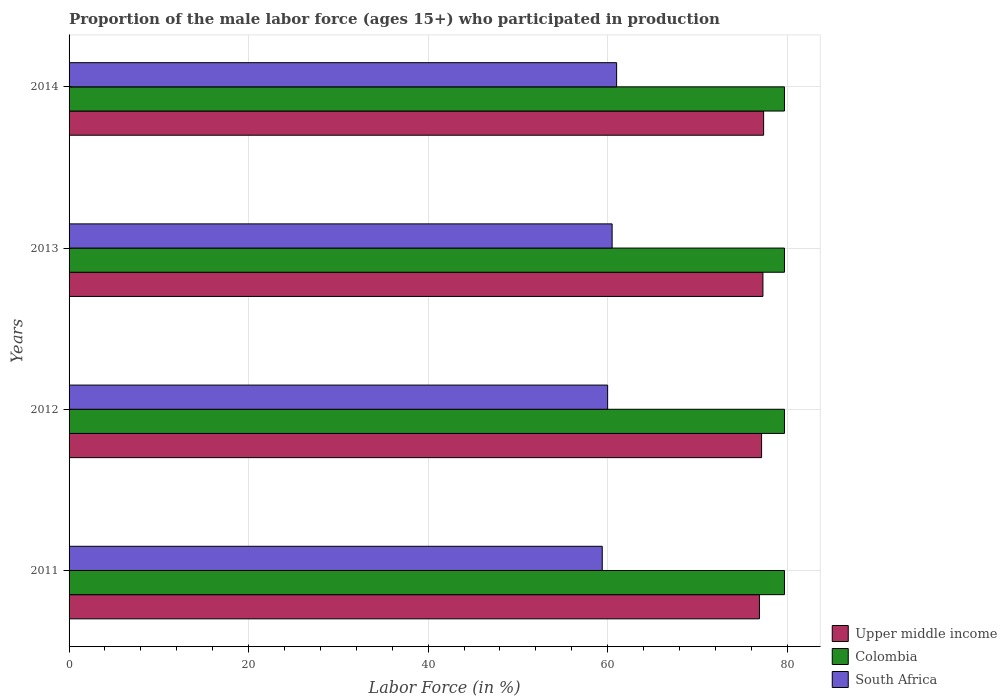How many different coloured bars are there?
Your answer should be compact. 3. Are the number of bars per tick equal to the number of legend labels?
Ensure brevity in your answer.  Yes. Are the number of bars on each tick of the Y-axis equal?
Ensure brevity in your answer.  Yes. How many bars are there on the 3rd tick from the top?
Keep it short and to the point. 3. How many bars are there on the 1st tick from the bottom?
Keep it short and to the point. 3. What is the proportion of the male labor force who participated in production in Colombia in 2011?
Ensure brevity in your answer.  79.7. Across all years, what is the maximum proportion of the male labor force who participated in production in Upper middle income?
Keep it short and to the point. 77.38. Across all years, what is the minimum proportion of the male labor force who participated in production in South Africa?
Offer a terse response. 59.4. In which year was the proportion of the male labor force who participated in production in Upper middle income maximum?
Keep it short and to the point. 2014. In which year was the proportion of the male labor force who participated in production in Upper middle income minimum?
Your answer should be very brief. 2011. What is the total proportion of the male labor force who participated in production in Upper middle income in the graph?
Provide a succinct answer. 308.74. What is the difference between the proportion of the male labor force who participated in production in South Africa in 2011 and that in 2013?
Your response must be concise. -1.1. What is the difference between the proportion of the male labor force who participated in production in South Africa in 2014 and the proportion of the male labor force who participated in production in Colombia in 2012?
Ensure brevity in your answer.  -18.7. What is the average proportion of the male labor force who participated in production in South Africa per year?
Offer a very short reply. 60.23. In the year 2012, what is the difference between the proportion of the male labor force who participated in production in South Africa and proportion of the male labor force who participated in production in Upper middle income?
Offer a very short reply. -17.15. In how many years, is the proportion of the male labor force who participated in production in South Africa greater than 56 %?
Your answer should be compact. 4. What is the ratio of the proportion of the male labor force who participated in production in South Africa in 2011 to that in 2014?
Your answer should be compact. 0.97. Is the proportion of the male labor force who participated in production in Colombia in 2011 less than that in 2014?
Your answer should be compact. No. Is the difference between the proportion of the male labor force who participated in production in South Africa in 2011 and 2012 greater than the difference between the proportion of the male labor force who participated in production in Upper middle income in 2011 and 2012?
Your answer should be compact. No. What is the difference between the highest and the lowest proportion of the male labor force who participated in production in Upper middle income?
Offer a terse response. 0.46. In how many years, is the proportion of the male labor force who participated in production in South Africa greater than the average proportion of the male labor force who participated in production in South Africa taken over all years?
Your response must be concise. 2. What does the 1st bar from the top in 2013 represents?
Give a very brief answer. South Africa. What does the 1st bar from the bottom in 2011 represents?
Ensure brevity in your answer.  Upper middle income. Is it the case that in every year, the sum of the proportion of the male labor force who participated in production in South Africa and proportion of the male labor force who participated in production in Colombia is greater than the proportion of the male labor force who participated in production in Upper middle income?
Keep it short and to the point. Yes. How many bars are there?
Your answer should be compact. 12. Are all the bars in the graph horizontal?
Provide a short and direct response. Yes. How many years are there in the graph?
Provide a succinct answer. 4. What is the difference between two consecutive major ticks on the X-axis?
Your response must be concise. 20. Are the values on the major ticks of X-axis written in scientific E-notation?
Provide a short and direct response. No. Where does the legend appear in the graph?
Your answer should be compact. Bottom right. How many legend labels are there?
Offer a very short reply. 3. How are the legend labels stacked?
Make the answer very short. Vertical. What is the title of the graph?
Your response must be concise. Proportion of the male labor force (ages 15+) who participated in production. What is the Labor Force (in %) in Upper middle income in 2011?
Your answer should be compact. 76.91. What is the Labor Force (in %) of Colombia in 2011?
Give a very brief answer. 79.7. What is the Labor Force (in %) in South Africa in 2011?
Your response must be concise. 59.4. What is the Labor Force (in %) of Upper middle income in 2012?
Your response must be concise. 77.15. What is the Labor Force (in %) in Colombia in 2012?
Your answer should be very brief. 79.7. What is the Labor Force (in %) of Upper middle income in 2013?
Offer a very short reply. 77.3. What is the Labor Force (in %) in Colombia in 2013?
Keep it short and to the point. 79.7. What is the Labor Force (in %) of South Africa in 2013?
Provide a short and direct response. 60.5. What is the Labor Force (in %) in Upper middle income in 2014?
Your answer should be very brief. 77.38. What is the Labor Force (in %) of Colombia in 2014?
Your response must be concise. 79.7. Across all years, what is the maximum Labor Force (in %) in Upper middle income?
Make the answer very short. 77.38. Across all years, what is the maximum Labor Force (in %) in Colombia?
Your answer should be compact. 79.7. Across all years, what is the minimum Labor Force (in %) of Upper middle income?
Your answer should be very brief. 76.91. Across all years, what is the minimum Labor Force (in %) of Colombia?
Your response must be concise. 79.7. Across all years, what is the minimum Labor Force (in %) of South Africa?
Offer a very short reply. 59.4. What is the total Labor Force (in %) in Upper middle income in the graph?
Ensure brevity in your answer.  308.74. What is the total Labor Force (in %) of Colombia in the graph?
Make the answer very short. 318.8. What is the total Labor Force (in %) in South Africa in the graph?
Your answer should be compact. 240.9. What is the difference between the Labor Force (in %) in Upper middle income in 2011 and that in 2012?
Make the answer very short. -0.24. What is the difference between the Labor Force (in %) of Colombia in 2011 and that in 2012?
Ensure brevity in your answer.  0. What is the difference between the Labor Force (in %) of Upper middle income in 2011 and that in 2013?
Offer a very short reply. -0.39. What is the difference between the Labor Force (in %) in Upper middle income in 2011 and that in 2014?
Ensure brevity in your answer.  -0.46. What is the difference between the Labor Force (in %) of Colombia in 2011 and that in 2014?
Provide a succinct answer. 0. What is the difference between the Labor Force (in %) in South Africa in 2011 and that in 2014?
Your answer should be compact. -1.6. What is the difference between the Labor Force (in %) in Upper middle income in 2012 and that in 2013?
Your answer should be very brief. -0.15. What is the difference between the Labor Force (in %) of Upper middle income in 2012 and that in 2014?
Provide a short and direct response. -0.23. What is the difference between the Labor Force (in %) in Colombia in 2012 and that in 2014?
Your answer should be very brief. 0. What is the difference between the Labor Force (in %) in Upper middle income in 2013 and that in 2014?
Your answer should be compact. -0.08. What is the difference between the Labor Force (in %) in Colombia in 2013 and that in 2014?
Make the answer very short. 0. What is the difference between the Labor Force (in %) in South Africa in 2013 and that in 2014?
Your answer should be very brief. -0.5. What is the difference between the Labor Force (in %) of Upper middle income in 2011 and the Labor Force (in %) of Colombia in 2012?
Your answer should be very brief. -2.79. What is the difference between the Labor Force (in %) of Upper middle income in 2011 and the Labor Force (in %) of South Africa in 2012?
Ensure brevity in your answer.  16.91. What is the difference between the Labor Force (in %) of Colombia in 2011 and the Labor Force (in %) of South Africa in 2012?
Ensure brevity in your answer.  19.7. What is the difference between the Labor Force (in %) of Upper middle income in 2011 and the Labor Force (in %) of Colombia in 2013?
Your response must be concise. -2.79. What is the difference between the Labor Force (in %) in Upper middle income in 2011 and the Labor Force (in %) in South Africa in 2013?
Offer a terse response. 16.41. What is the difference between the Labor Force (in %) in Upper middle income in 2011 and the Labor Force (in %) in Colombia in 2014?
Make the answer very short. -2.79. What is the difference between the Labor Force (in %) of Upper middle income in 2011 and the Labor Force (in %) of South Africa in 2014?
Provide a short and direct response. 15.91. What is the difference between the Labor Force (in %) in Upper middle income in 2012 and the Labor Force (in %) in Colombia in 2013?
Make the answer very short. -2.55. What is the difference between the Labor Force (in %) of Upper middle income in 2012 and the Labor Force (in %) of South Africa in 2013?
Provide a short and direct response. 16.65. What is the difference between the Labor Force (in %) in Colombia in 2012 and the Labor Force (in %) in South Africa in 2013?
Make the answer very short. 19.2. What is the difference between the Labor Force (in %) of Upper middle income in 2012 and the Labor Force (in %) of Colombia in 2014?
Make the answer very short. -2.55. What is the difference between the Labor Force (in %) of Upper middle income in 2012 and the Labor Force (in %) of South Africa in 2014?
Offer a terse response. 16.15. What is the difference between the Labor Force (in %) of Colombia in 2012 and the Labor Force (in %) of South Africa in 2014?
Provide a short and direct response. 18.7. What is the difference between the Labor Force (in %) of Upper middle income in 2013 and the Labor Force (in %) of Colombia in 2014?
Ensure brevity in your answer.  -2.4. What is the difference between the Labor Force (in %) of Upper middle income in 2013 and the Labor Force (in %) of South Africa in 2014?
Offer a very short reply. 16.3. What is the average Labor Force (in %) in Upper middle income per year?
Your answer should be very brief. 77.19. What is the average Labor Force (in %) of Colombia per year?
Offer a terse response. 79.7. What is the average Labor Force (in %) of South Africa per year?
Ensure brevity in your answer.  60.23. In the year 2011, what is the difference between the Labor Force (in %) in Upper middle income and Labor Force (in %) in Colombia?
Offer a very short reply. -2.79. In the year 2011, what is the difference between the Labor Force (in %) of Upper middle income and Labor Force (in %) of South Africa?
Provide a short and direct response. 17.51. In the year 2011, what is the difference between the Labor Force (in %) in Colombia and Labor Force (in %) in South Africa?
Your response must be concise. 20.3. In the year 2012, what is the difference between the Labor Force (in %) of Upper middle income and Labor Force (in %) of Colombia?
Your response must be concise. -2.55. In the year 2012, what is the difference between the Labor Force (in %) of Upper middle income and Labor Force (in %) of South Africa?
Offer a terse response. 17.15. In the year 2013, what is the difference between the Labor Force (in %) in Upper middle income and Labor Force (in %) in Colombia?
Your answer should be very brief. -2.4. In the year 2013, what is the difference between the Labor Force (in %) in Upper middle income and Labor Force (in %) in South Africa?
Provide a short and direct response. 16.8. In the year 2013, what is the difference between the Labor Force (in %) of Colombia and Labor Force (in %) of South Africa?
Provide a short and direct response. 19.2. In the year 2014, what is the difference between the Labor Force (in %) of Upper middle income and Labor Force (in %) of Colombia?
Offer a very short reply. -2.32. In the year 2014, what is the difference between the Labor Force (in %) of Upper middle income and Labor Force (in %) of South Africa?
Keep it short and to the point. 16.38. In the year 2014, what is the difference between the Labor Force (in %) of Colombia and Labor Force (in %) of South Africa?
Your answer should be very brief. 18.7. What is the ratio of the Labor Force (in %) of Upper middle income in 2011 to that in 2013?
Provide a short and direct response. 0.99. What is the ratio of the Labor Force (in %) in Colombia in 2011 to that in 2013?
Provide a succinct answer. 1. What is the ratio of the Labor Force (in %) of South Africa in 2011 to that in 2013?
Your answer should be very brief. 0.98. What is the ratio of the Labor Force (in %) in South Africa in 2011 to that in 2014?
Provide a short and direct response. 0.97. What is the ratio of the Labor Force (in %) in Upper middle income in 2012 to that in 2013?
Offer a very short reply. 1. What is the ratio of the Labor Force (in %) of Colombia in 2012 to that in 2013?
Offer a very short reply. 1. What is the ratio of the Labor Force (in %) in South Africa in 2012 to that in 2013?
Your answer should be compact. 0.99. What is the ratio of the Labor Force (in %) of South Africa in 2012 to that in 2014?
Your answer should be very brief. 0.98. What is the ratio of the Labor Force (in %) of Upper middle income in 2013 to that in 2014?
Offer a terse response. 1. What is the ratio of the Labor Force (in %) in Colombia in 2013 to that in 2014?
Provide a succinct answer. 1. What is the ratio of the Labor Force (in %) of South Africa in 2013 to that in 2014?
Offer a terse response. 0.99. What is the difference between the highest and the second highest Labor Force (in %) of Upper middle income?
Provide a short and direct response. 0.08. What is the difference between the highest and the second highest Labor Force (in %) in Colombia?
Offer a very short reply. 0. What is the difference between the highest and the second highest Labor Force (in %) of South Africa?
Ensure brevity in your answer.  0.5. What is the difference between the highest and the lowest Labor Force (in %) of Upper middle income?
Your answer should be compact. 0.46. 